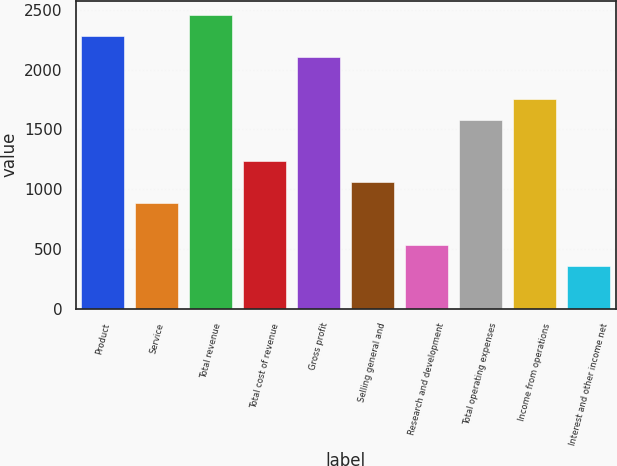Convert chart to OTSL. <chart><loc_0><loc_0><loc_500><loc_500><bar_chart><fcel>Product<fcel>Service<fcel>Total revenue<fcel>Total cost of revenue<fcel>Gross profit<fcel>Selling general and<fcel>Research and development<fcel>Total operating expenses<fcel>Income from operations<fcel>Interest and other income net<nl><fcel>2280.82<fcel>884.82<fcel>2455.32<fcel>1233.82<fcel>2106.32<fcel>1059.32<fcel>535.82<fcel>1582.82<fcel>1757.32<fcel>361.32<nl></chart> 